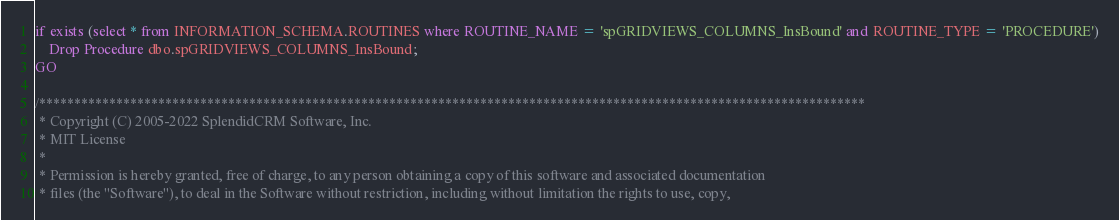Convert code to text. <code><loc_0><loc_0><loc_500><loc_500><_SQL_>if exists (select * from INFORMATION_SCHEMA.ROUTINES where ROUTINE_NAME = 'spGRIDVIEWS_COLUMNS_InsBound' and ROUTINE_TYPE = 'PROCEDURE')
	Drop Procedure dbo.spGRIDVIEWS_COLUMNS_InsBound;
GO
 
/**********************************************************************************************************************
 * Copyright (C) 2005-2022 SplendidCRM Software, Inc. 
 * MIT License
 * 
 * Permission is hereby granted, free of charge, to any person obtaining a copy of this software and associated documentation 
 * files (the "Software"), to deal in the Software without restriction, including without limitation the rights to use, copy, </code> 